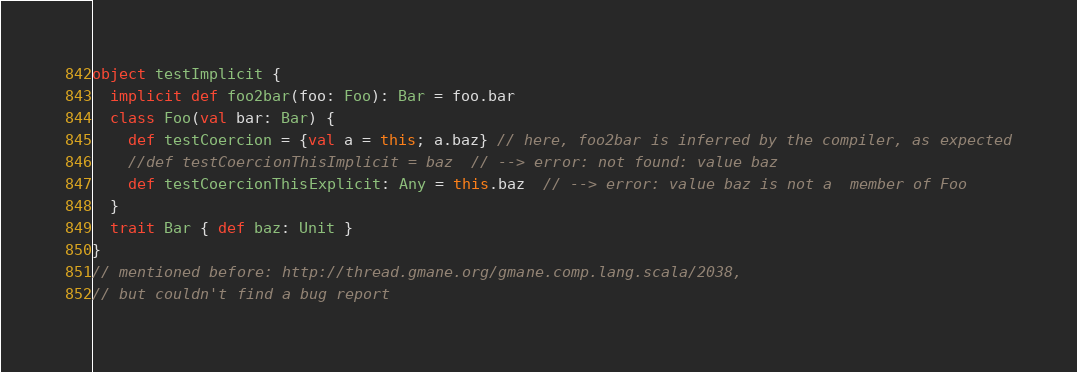Convert code to text. <code><loc_0><loc_0><loc_500><loc_500><_Scala_>object testImplicit {
  implicit def foo2bar(foo: Foo): Bar = foo.bar
  class Foo(val bar: Bar) {
    def testCoercion = {val a = this; a.baz} // here, foo2bar is inferred by the compiler, as expected
    //def testCoercionThisImplicit = baz  // --> error: not found: value baz
    def testCoercionThisExplicit: Any = this.baz  // --> error: value baz is not a  member of Foo
  }
  trait Bar { def baz: Unit }
}
// mentioned before: http://thread.gmane.org/gmane.comp.lang.scala/2038,
// but couldn't find a bug report
</code> 